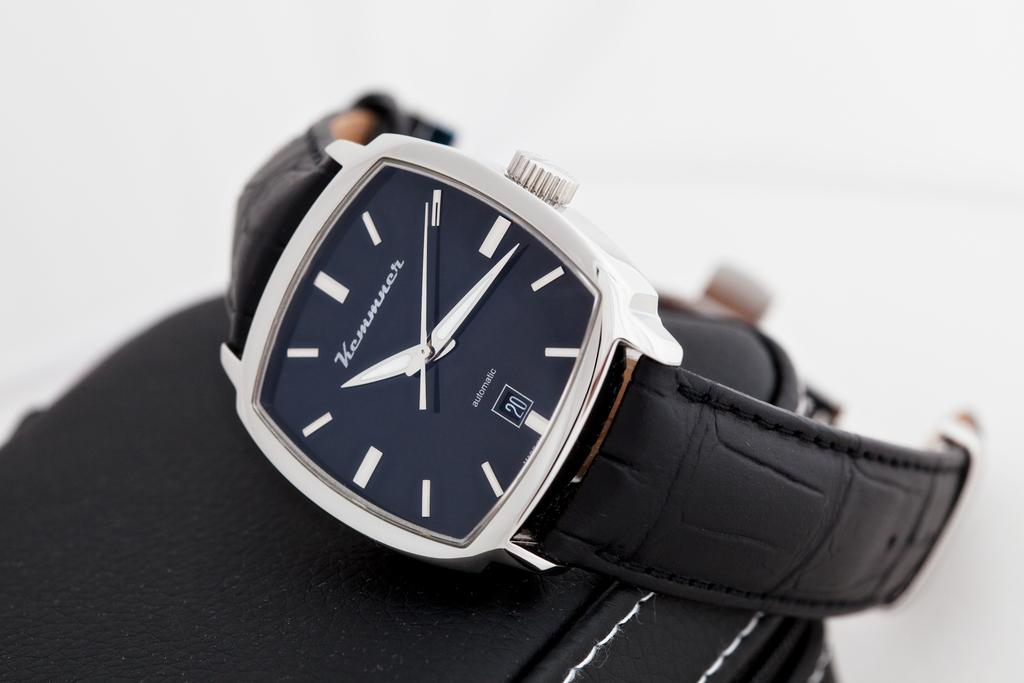<image>
Present a compact description of the photo's key features. a black watch with a silver frame that is labeled 'kemmncr' on the face 